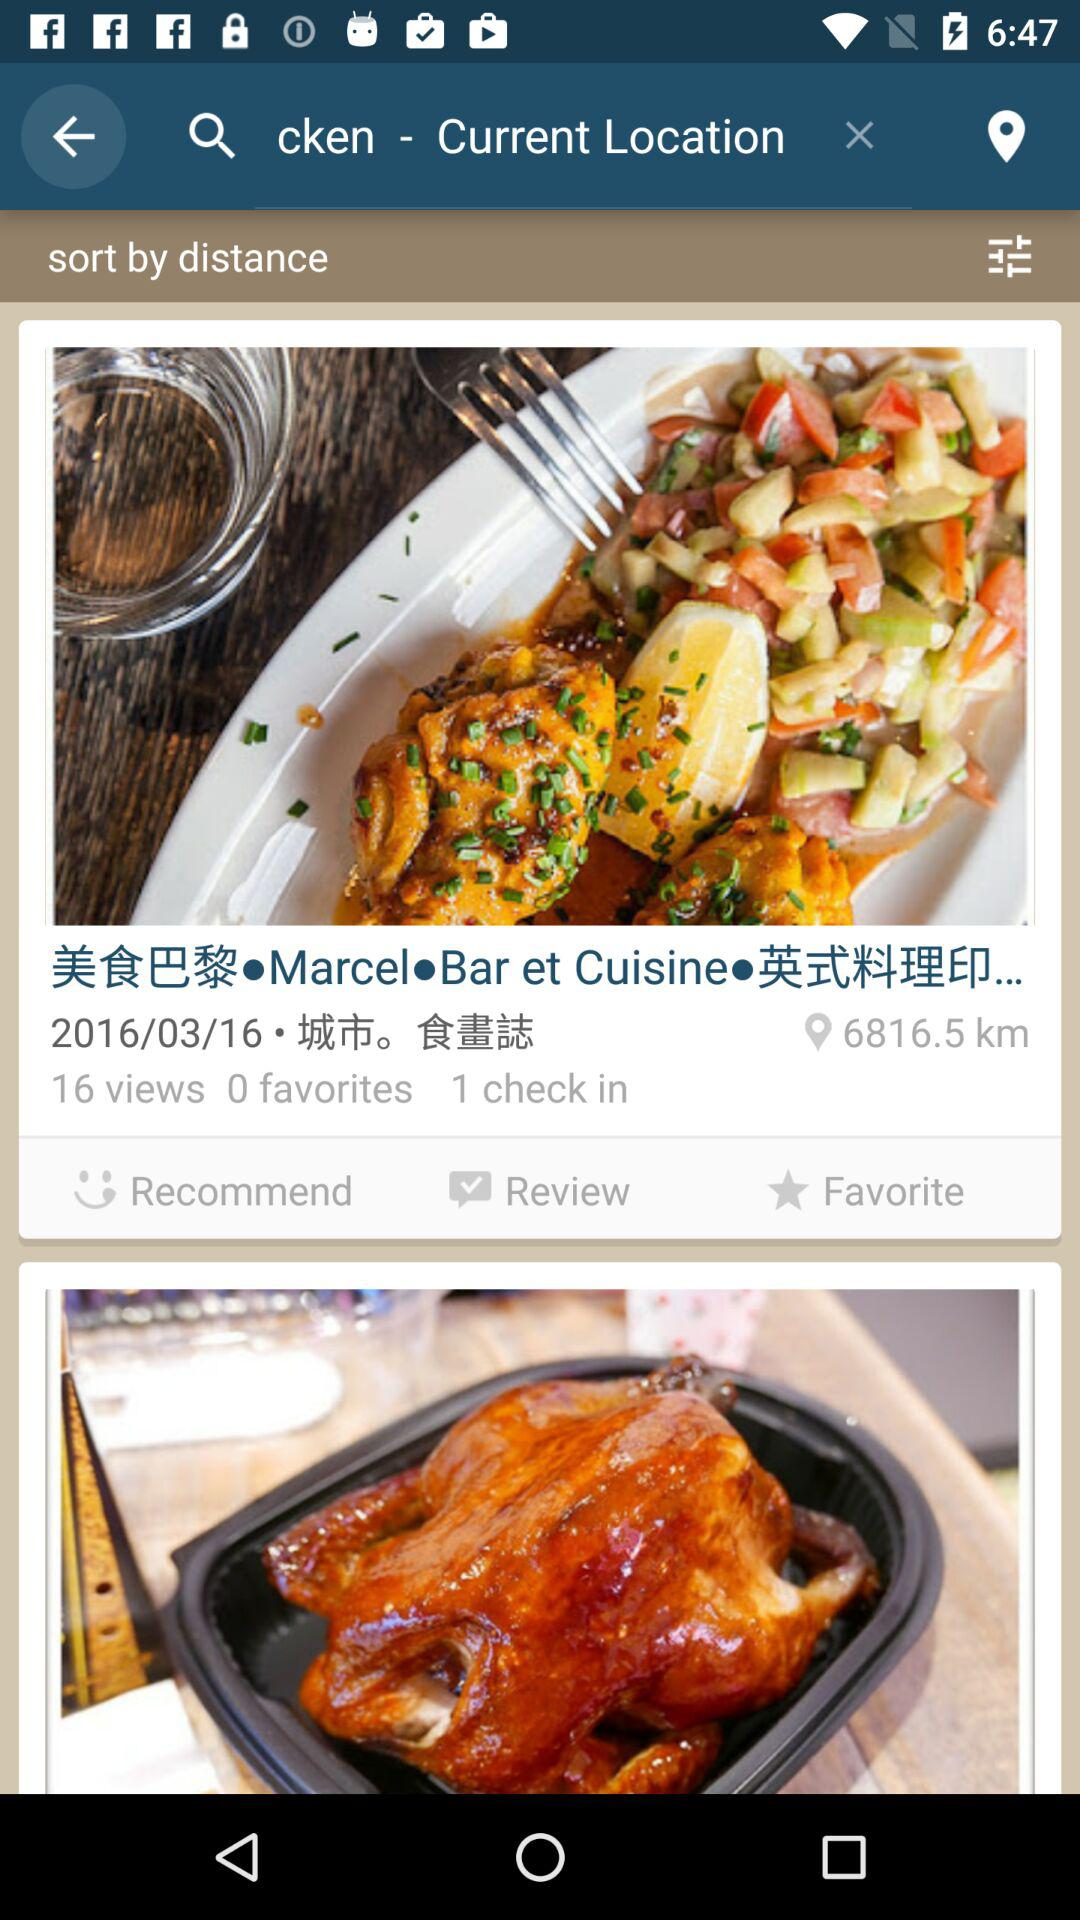How many views are there of the restaurant? There are 16 views of the restaurant. 